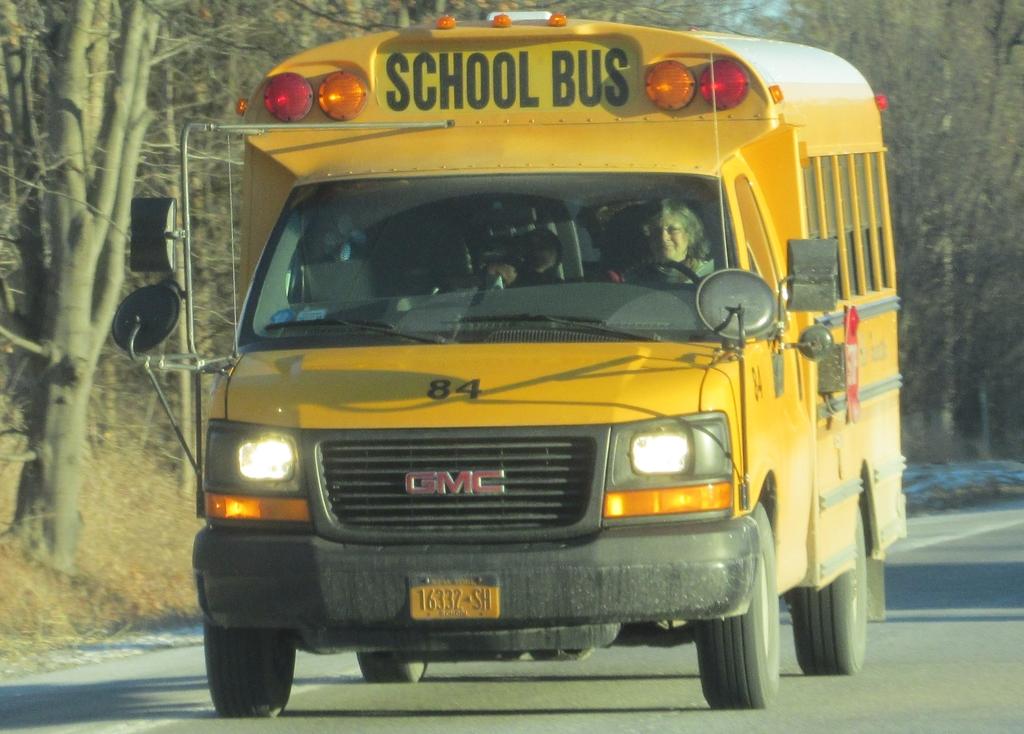What kind of vehicle is this?
Give a very brief answer. School bus. What type of bus is this?
Keep it short and to the point. School. 